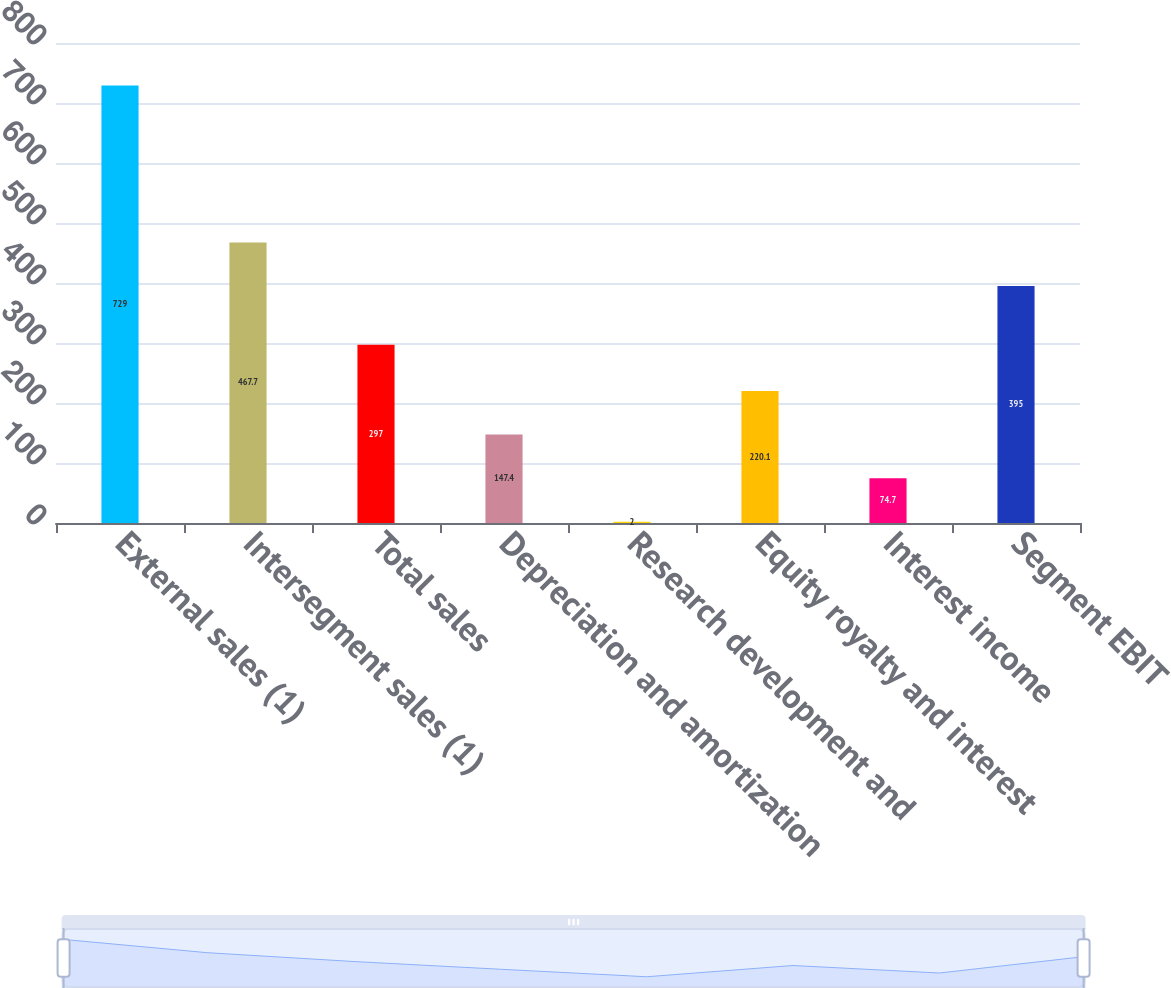Convert chart. <chart><loc_0><loc_0><loc_500><loc_500><bar_chart><fcel>External sales (1)<fcel>Intersegment sales (1)<fcel>Total sales<fcel>Depreciation and amortization<fcel>Research development and<fcel>Equity royalty and interest<fcel>Interest income<fcel>Segment EBIT<nl><fcel>729<fcel>467.7<fcel>297<fcel>147.4<fcel>2<fcel>220.1<fcel>74.7<fcel>395<nl></chart> 